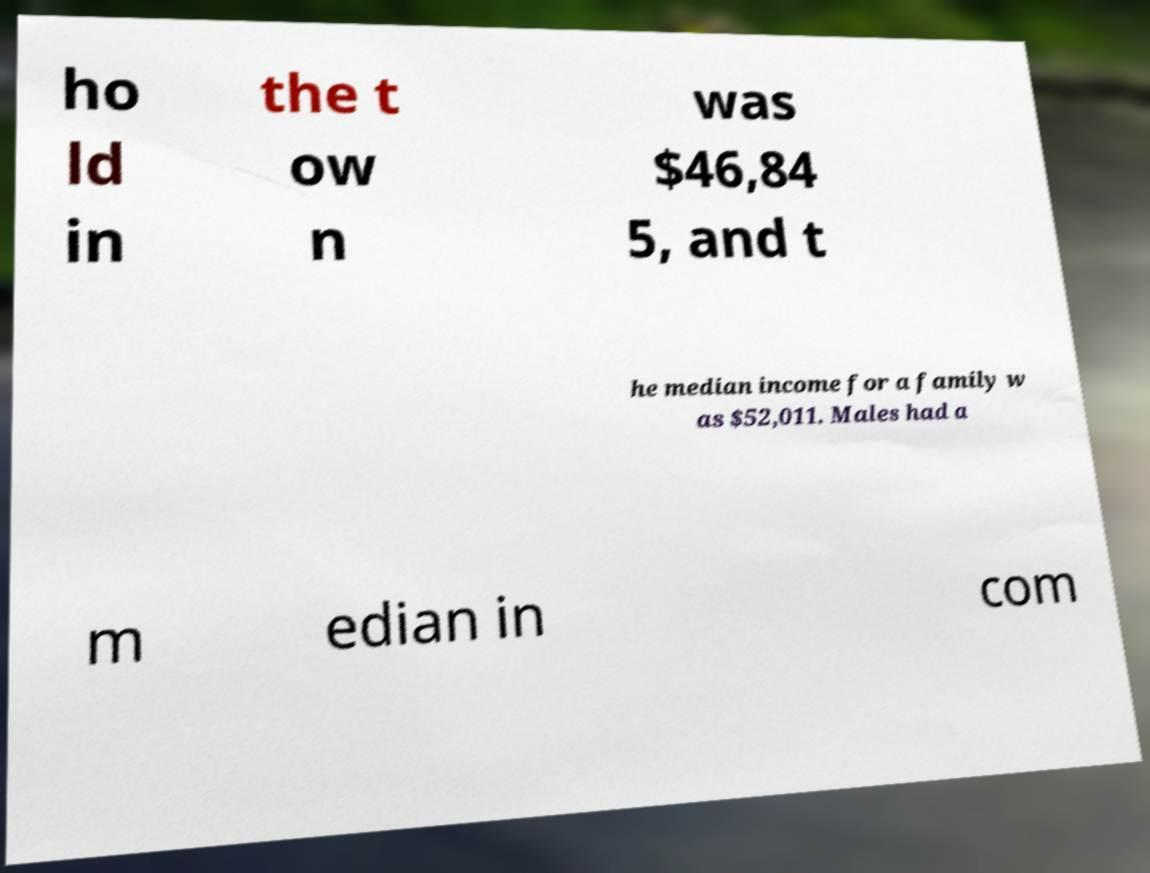What messages or text are displayed in this image? I need them in a readable, typed format. ho ld in the t ow n was $46,84 5, and t he median income for a family w as $52,011. Males had a m edian in com 